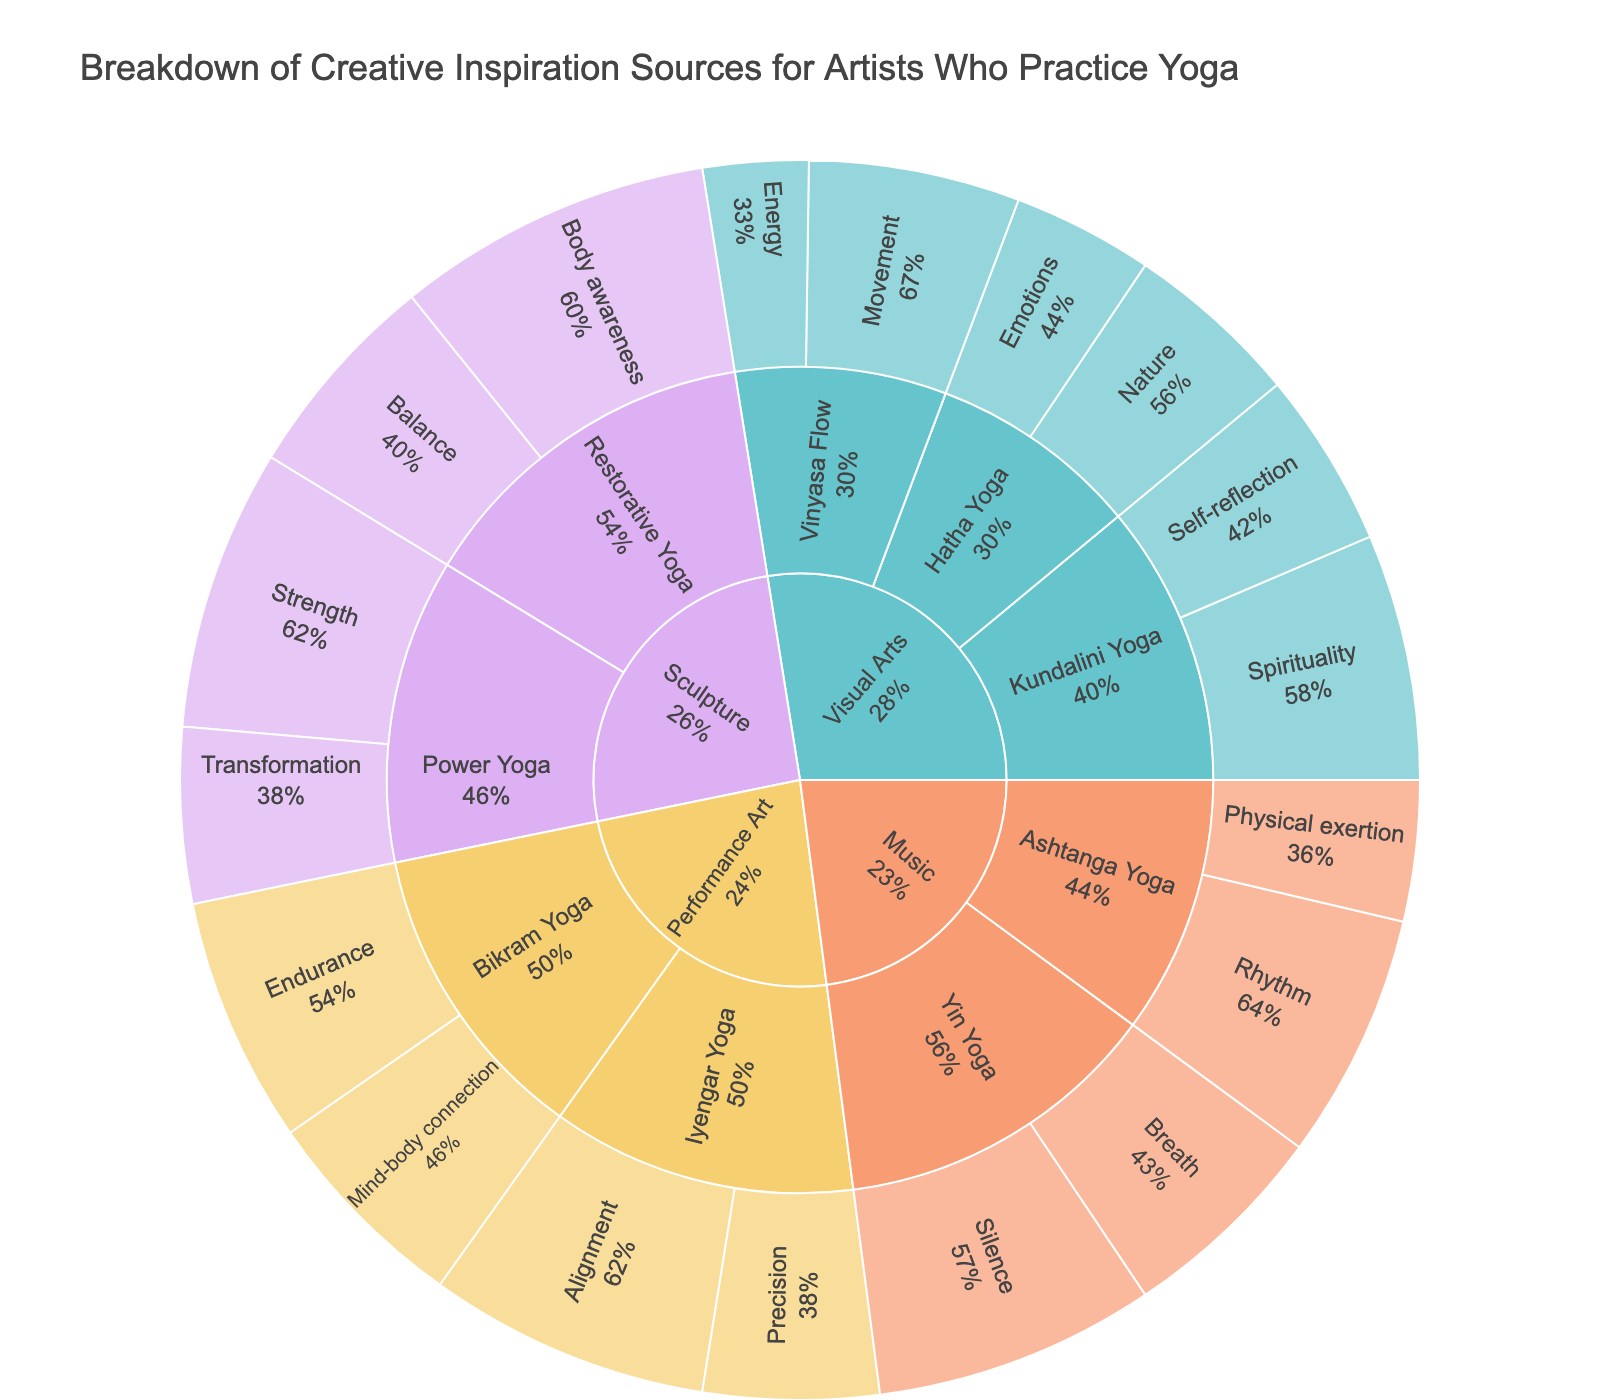What is the title of the figure? The title is usually displayed at the top of the plot, providing a quick understanding of what the data represents. By looking at the top of the plot, we can see that the title is "Breakdown of Creative Inspiration Sources for Artists Who Practice Yoga".
Answer: Breakdown of Creative Inspiration Sources for Artists Who Practice Yoga Which art form has the highest percentage of inspiration from Spirituality? By examining the sunburst plot, we can see that the "Visual Arts" section under "Kundalini Yoga" has an inspiration source labeled "Spirituality" with percentage details showing it has the highest.
Answer: Visual Arts What percentage of Visual Arts inspiration comes from Nature under Hatha Yoga? The plot shows the breakdown of inspiration sources for Visual Arts under Hatha Yoga. By finding "Nature" in this section, the percentage labeled next to it indicates 25%.
Answer: 25% Which yoga type under Music has the highest percentage inspiration source? By looking at the Music section and comparing the sub-categories (Yin Yoga and Ashtanga Yoga), we can see that "Silence" under "Yin Yoga" has the highest percentage of 40%.
Answer: Yin Yoga How does the percentage of Sculpture's inspiration from Balance under Restorative Yoga compare to Strength under Power Yoga? To compare these two segments: Sculpture's Balance under Restorative Yoga is 30%, and Sculpture's Strength under Power Yoga is 40%. Therefore, Strength under Power Yoga has a higher percentage.
Answer: Strength under Power Yoga is higher What is the total percentage of inspiration sources coming from Music? To find this, add up all the percentage values within the Music sections: (40% from Silence under Yin Yoga) + (30% from Breath under Yin Yoga) + (35% from Rhythm under Ashtanga Yoga) + (20% from Physical exertion under Ashtanga Yoga). The total is 40 + 30 + 35 + 20 = 125%.
Answer: 125% Which art form has the most diverse inspiration sources in terms of unique categories? To determine this, we compare the number of unique inspiration sources listed under each art form. Visual Arts has the most diverse sources, covering Nature, Emotions, Movement, Energy, Spirituality, and Self-reflection.
Answer: Visual Arts What is the inspiration source with the highest percentage in Performance Art? By focusing on the Performance Art section and comparing the percentages, "Alignment" under Iyengar Yoga has the highest percentage at 40%.
Answer: Alignment What is the least common inspiration source for Performance Art? Looking at the Performance Art section and comparing all inspiration source percentages, "Precision" under Iyengar Yoga has the lowest percentage at 25%.
Answer: Precision 